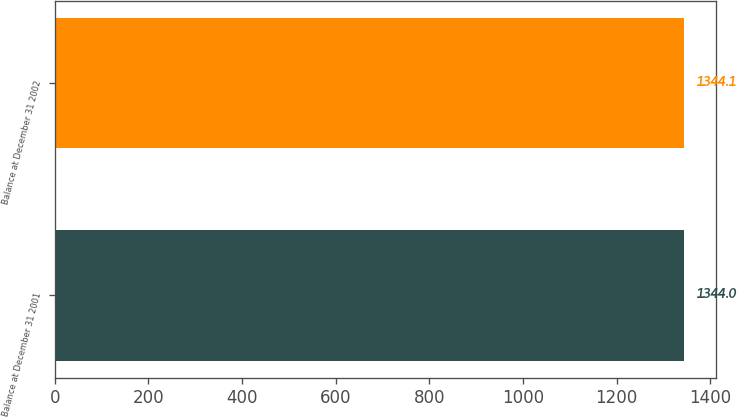<chart> <loc_0><loc_0><loc_500><loc_500><bar_chart><fcel>Balance at December 31 2001<fcel>Balance at December 31 2002<nl><fcel>1344<fcel>1344.1<nl></chart> 